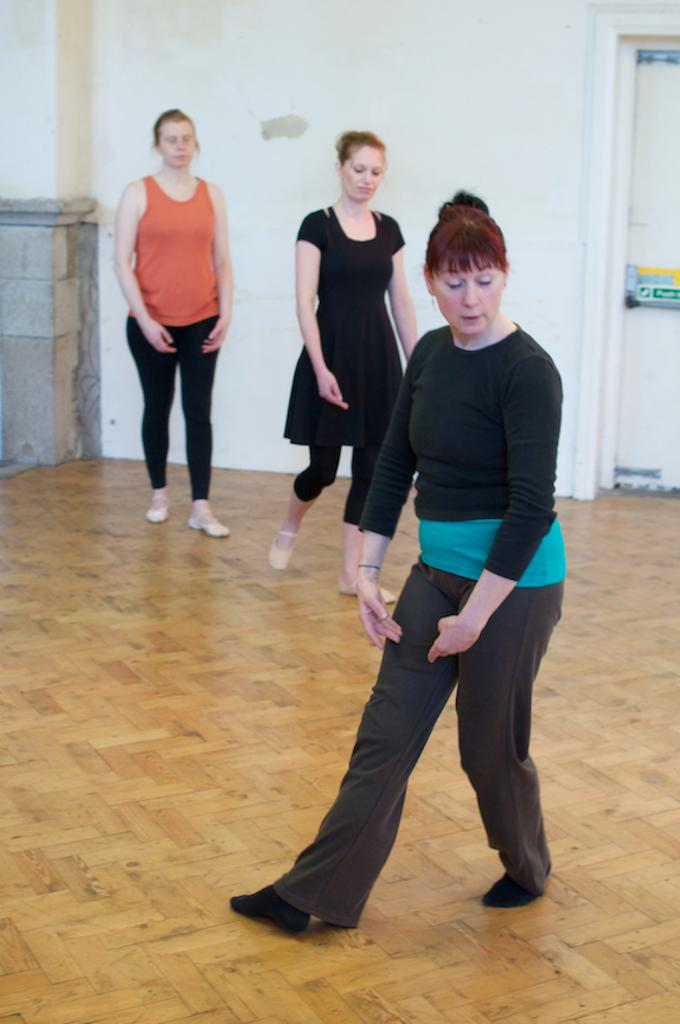How many women are present in the image? There are three women in the image. What are the women doing in the image? The women are standing on the ground. What colors are the dresses worn by the women? One woman is wearing a black dress, and another is wearing an orange dress. What can be seen in the background of the image? There is a door visible in the background of the image. Can you see any steam coming from the women's dresses in the image? No, there is no steam visible in the image. Are the women swimming in the image? No, the women are standing on the ground, not swimming. 